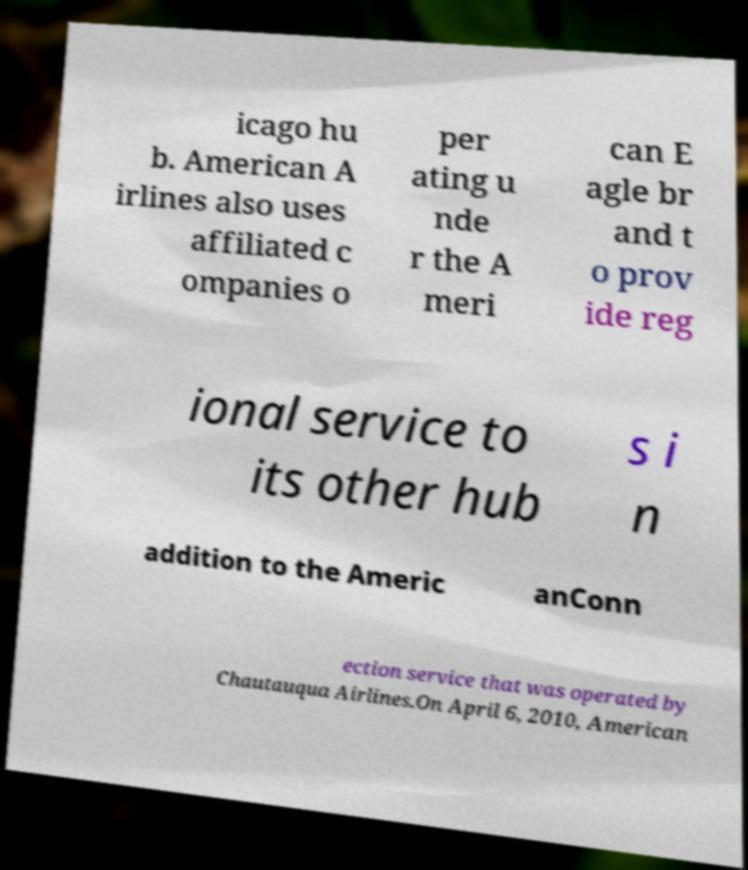There's text embedded in this image that I need extracted. Can you transcribe it verbatim? icago hu b. American A irlines also uses affiliated c ompanies o per ating u nde r the A meri can E agle br and t o prov ide reg ional service to its other hub s i n addition to the Americ anConn ection service that was operated by Chautauqua Airlines.On April 6, 2010, American 